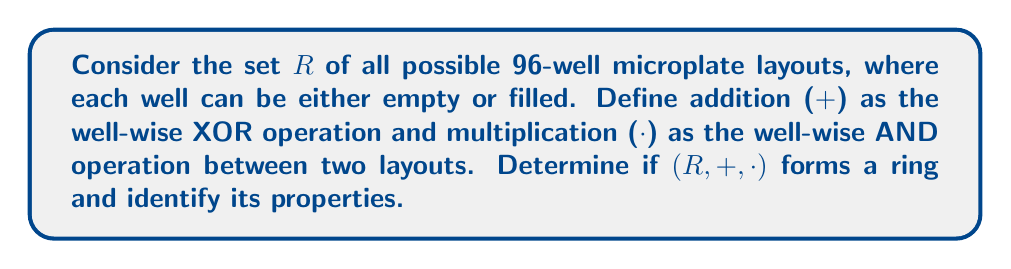Teach me how to tackle this problem. To determine if $(R, +, \cdot)$ forms a ring and identify its properties, we need to check the ring axioms:

1. $(R, +)$ is an abelian group:
   a) Closure: The XOR of two layouts results in another valid layout.
   b) Associativity: $(A + B) + C = A + (B + C)$ for all layouts $A, B, C$.
   c) Identity: The layout with all wells empty is the additive identity.
   d) Inverse: Each layout is its own inverse under XOR.
   e) Commutativity: $A + B = B + A$ for all layouts $A, B$.

2. $(R, \cdot)$ is a monoid:
   a) Closure: The AND of two layouts results in another valid layout.
   b) Associativity: $(A \cdot B) \cdot C = A \cdot (B \cdot C)$ for all layouts $A, B, C$.
   c) Identity: The layout with all wells filled is the multiplicative identity.

3. Distributivity:
   $A \cdot (B + C) = (A \cdot B) + (A \cdot C)$ and $(B + C) \cdot A = (B \cdot A) + (C \cdot A)$ for all layouts $A, B, C$.

All these properties hold for the given operations, so $(R, +, \cdot)$ forms a ring.

Additional properties:
1. Commutative: $A \cdot B = B \cdot A$ for all layouts $A, B$.
2. Boolean ring: $A \cdot A = A$ for all layouts $A$.
3. Characteristic 2: $A + A = 0$ for all layouts $A$.
4. Finite: There are $2^{96}$ possible layouts.
Answer: $(R, +, \cdot)$ forms a commutative Boolean ring of characteristic 2 with $2^{96}$ elements. 